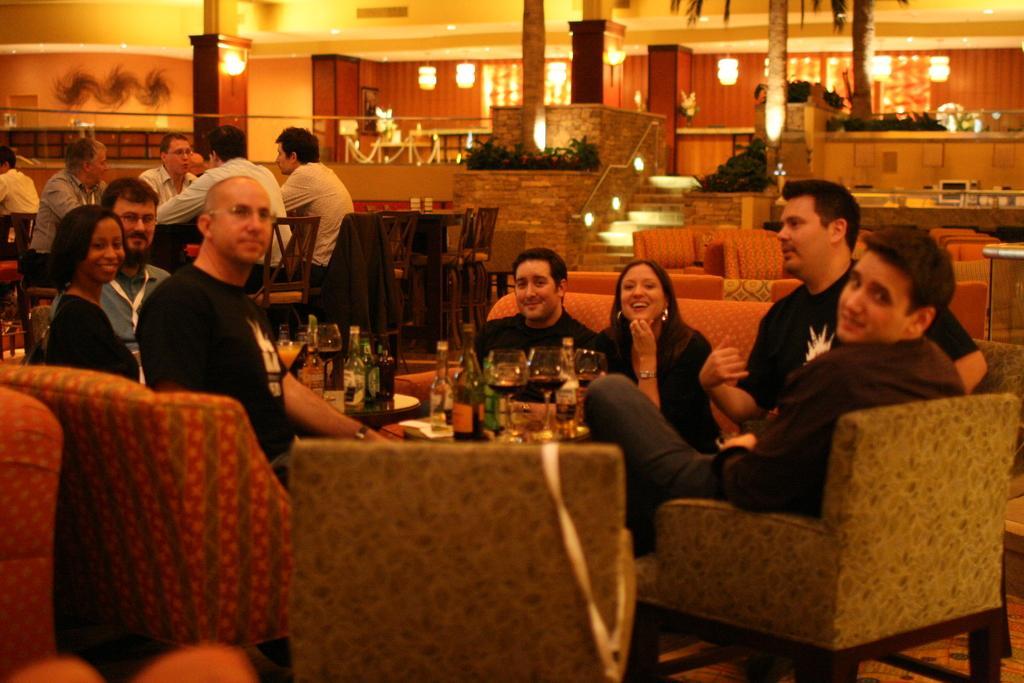In one or two sentences, can you explain what this image depicts? In this picture I can see few people seated and I can see bottles, glasses and a plate on the table and I can see smile on their faces and I can see few chairs, tables and lights and couple of trees and plants and I can see lights to the ceiling, it looks like a restaurant. 